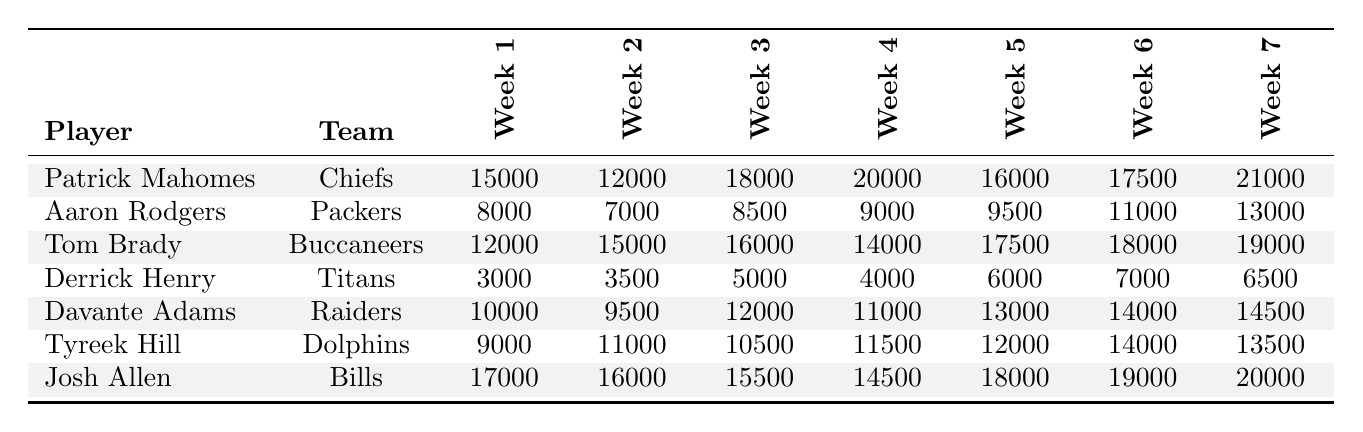What was the total number of social media mentions for Patrick Mahomes from week 1 to week 7? To find the total mentions for Patrick Mahomes, I will add each week's mentions: 15000 (week 1) + 12000 (week 2) + 18000 (week 3) + 20000 (week 4) + 16000 (week 5) + 17500 (week 6) + 21000 (week 7) = 109500.
Answer: 109500 Which player received the highest social media mentions in week 4? In week 4, I compare the mentions for each player: Patrick Mahomes (20000), Aaron Rodgers (9000), Tom Brady (14000), Derrick Henry (4000), Davante Adams (11000), Tyreek Hill (11500), and Josh Allen (14500). The highest is Patrick Mahomes with 20000 mentions.
Answer: Patrick Mahomes What was the average number of social media mentions for Tom Brady across all weeks? I calculate the average by adding all the mentions: 12000 + 15000 + 16000 + 14000 + 17500 + 18000 + 19000 = 111500. Then, I divide this by 7 (number of weeks): 111500 / 7 ≈ 15928.57.
Answer: approximately 15929 Did Tyreek Hill have more mentions than Derrick Henry in week 5? For week 5, Tyreek Hill had 12000 mentions, and Derrick Henry had 6000 mentions. Since 12000 > 6000, Tyreek Hill had more mentions.
Answer: Yes Which player had the most consistent growth in mentions from week 1 to week 7? I analyze the growth for each player by examining the differences between their week 1 and week 7 mentions. Patrick Mahomes rose from 15000 to 21000 (+6000), Aaron Rodgers from 8000 to 13000 (+5000), Tom Brady from 12000 to 19000 (+7000), Derrick Henry from 3000 to 6500 (+3500), Davante Adams from 10000 to 14500 (+4500), Tyreek Hill from 9000 to 13500 (+4500), and Josh Allen from 17000 to 20000 (+3000). Tom Brady had the highest increase with +7000.
Answer: Tom Brady What is the difference in mentions between the highest and lowest player in week 6? I compare week 6 mentions: Patrick Mahomes (17500), Aaron Rodgers (11000), Tom Brady (18000), Derrick Henry (7000), Davante Adams (14000), Tyreek Hill (14000), and Josh Allen (19000). The highest is Josh Allen with 19000, and the lowest is Derrick Henry with 7000. The difference is 19000 - 7000 = 12000.
Answer: 12000 How many total mentions were recorded for all players combined in week 2? I sum the mentions for week 2: Patrick Mahomes (12000) + Aaron Rodgers (7000) + Tom Brady (15000) + Derrick Henry (3500) + Davante Adams (9500) + Tyreek Hill (11000) + Josh Allen (16000) = 72000.
Answer: 72000 Which player had the second-highest number of mentions in week 3? For week 3, I compare mentions: Patrick Mahomes (18000), Aaron Rodgers (8500), Tom Brady (16000), Derrick Henry (5000), Davante Adams (12000), Tyreek Hill (10500), and Josh Allen (15500). The second-highest after Patrick Mahomes is Tom Brady with 16000 mentions.
Answer: Tom Brady 